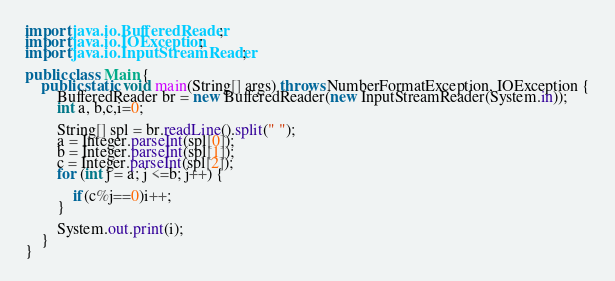<code> <loc_0><loc_0><loc_500><loc_500><_Java_>import java.io.BufferedReader;
import java.io.IOException;
import java.io.InputStreamReader;

public class Main {
	public static void main(String[] args) throws NumberFormatException, IOException {
		BufferedReader br = new BufferedReader(new InputStreamReader(System.in));
		int a, b,c,i=0;

		String[] spl = br.readLine().split(" ");
		a = Integer.parseInt(spl[0]);
		b = Integer.parseInt(spl[1]);
		c = Integer.parseInt(spl[2]);
		for (int j = a; j <=b; j++) {

			if(c%j==0)i++;
		}

		System.out.print(i);
	}
}</code> 